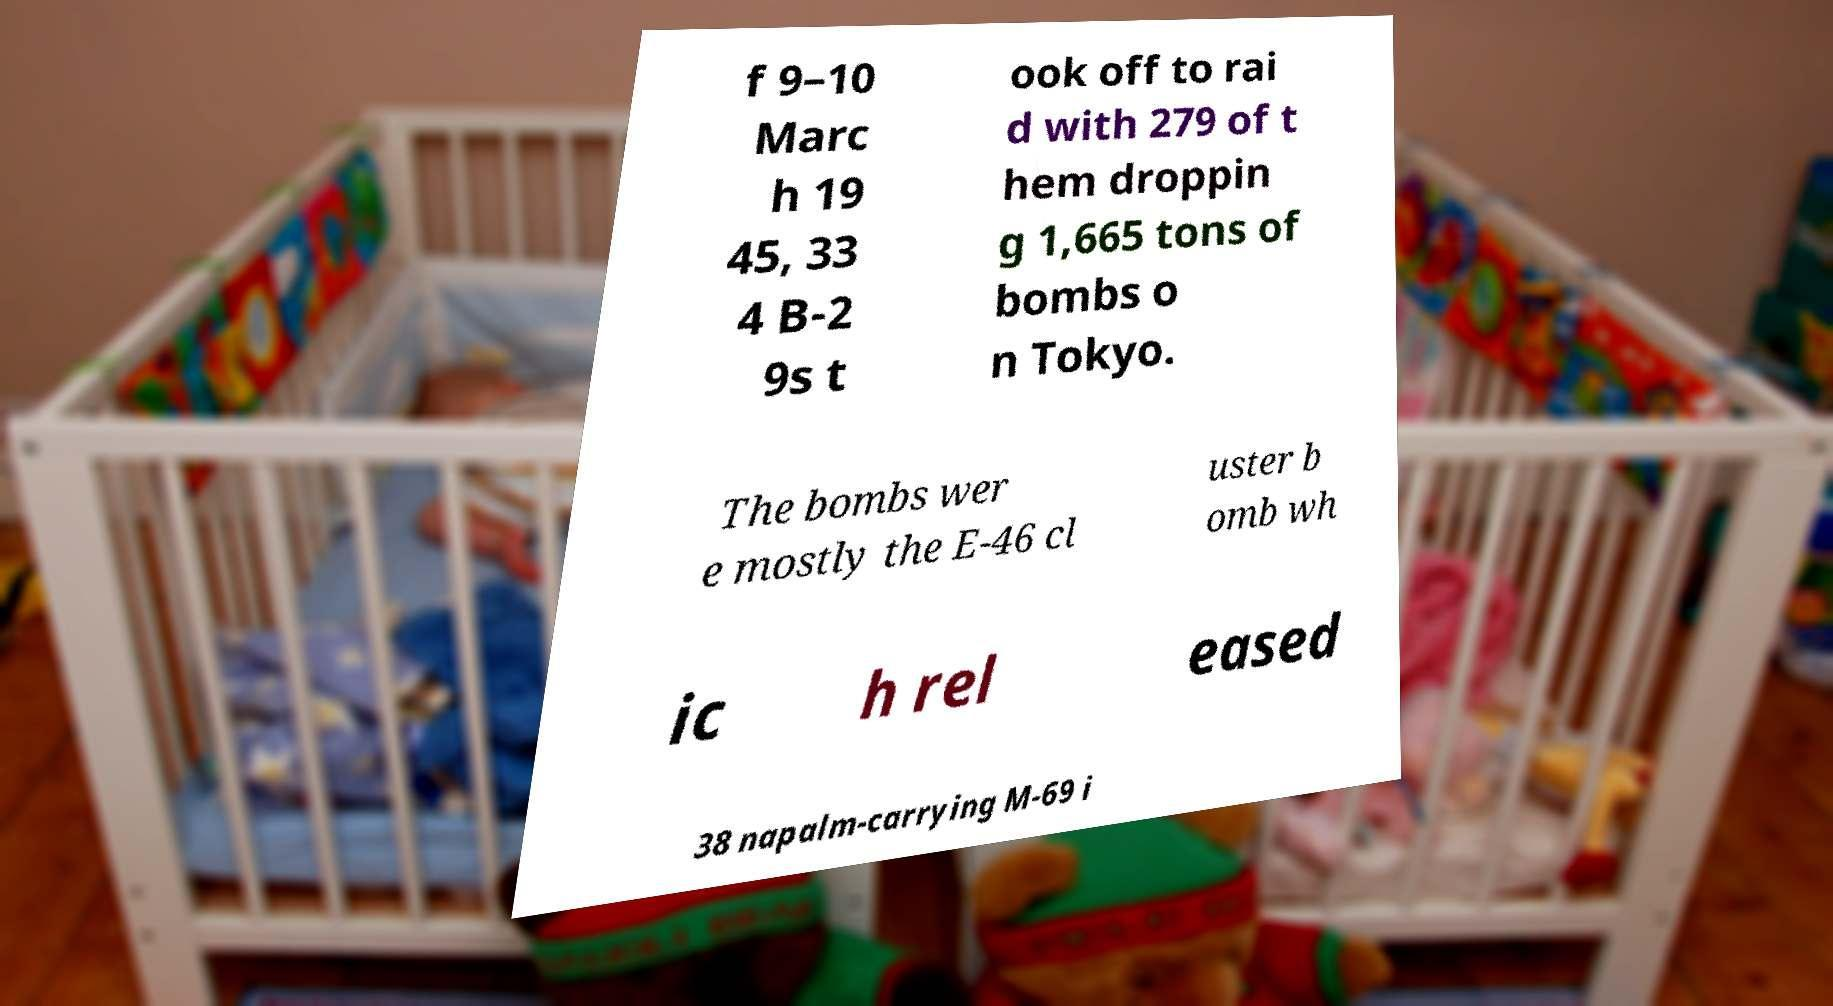For documentation purposes, I need the text within this image transcribed. Could you provide that? f 9–10 Marc h 19 45, 33 4 B-2 9s t ook off to rai d with 279 of t hem droppin g 1,665 tons of bombs o n Tokyo. The bombs wer e mostly the E-46 cl uster b omb wh ic h rel eased 38 napalm-carrying M-69 i 